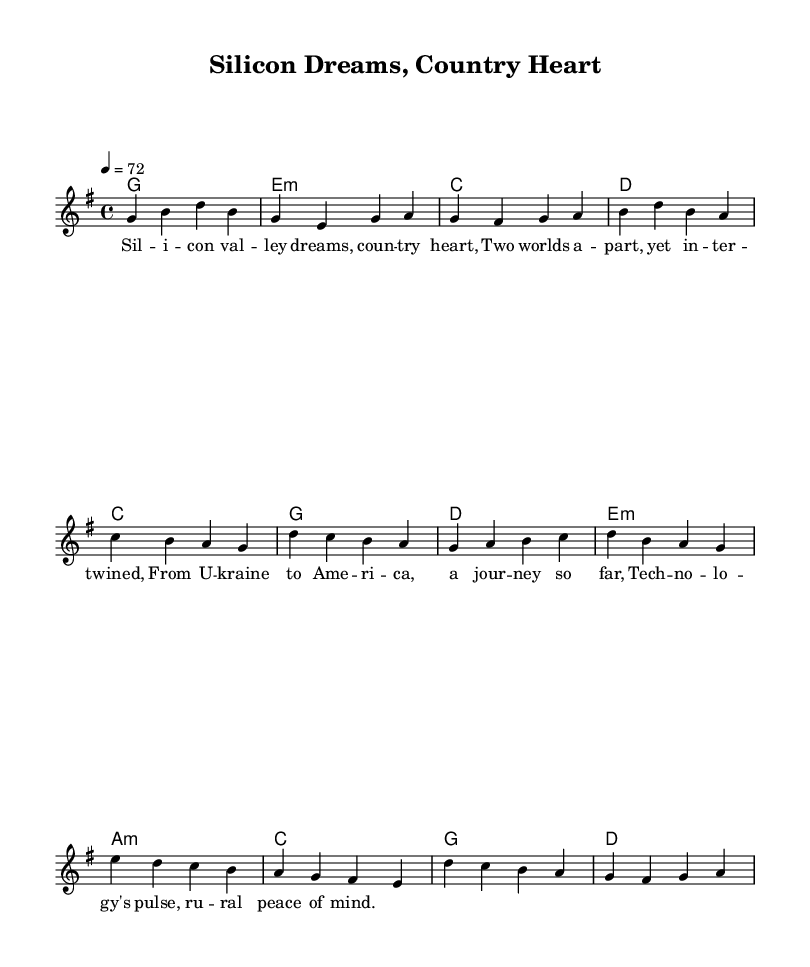What is the key signature of this music? The key signature is G major, which has one sharp (F#).
Answer: G major What is the time signature of the piece? The time signature is 4/4, indicating four beats per measure.
Answer: 4/4 What is the tempo marking for the piece? The tempo marking is a quarter note equals seventy-two beats per minute.
Answer: 72 How many measures are in the verse section? The verse section has four measures, as indicated by the melody notation.
Answer: 4 What is the first chord of the harmony section? The first chord is G major, represented as a G in the chord symbols.
Answer: G How does the chorus contrast with the verse musically? The chorus has a different melodic pattern and shifts towards more tension with new chord changes, demonstrating a lift compared to the verse.
Answer: Different melodic pattern What themes are explored in the lyrics? The lyrics explore the contrast between technology in Silicon Valley and the simplicity of small-town life, reflecting a personal journey.
Answer: Cultural contrast 